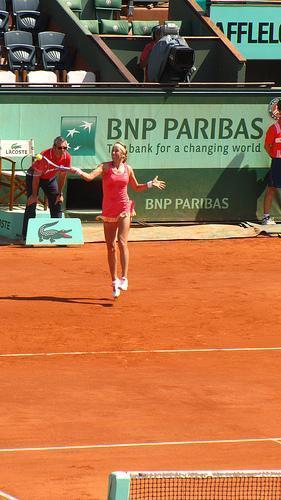How many players are seen?
Give a very brief answer. 1. 